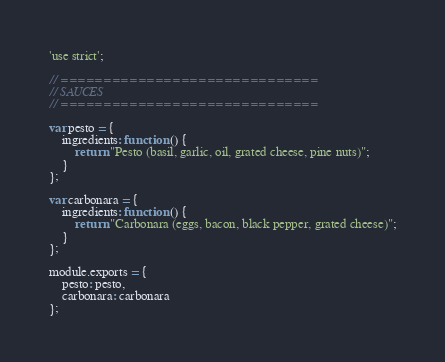Convert code to text. <code><loc_0><loc_0><loc_500><loc_500><_JavaScript_>'use strict';

// ==============================
// SAUCES
// ==============================

var pesto = {
    ingredients: function () {
        return "Pesto (basil, garlic, oil, grated cheese, pine nuts)";
    }
};

var carbonara = {
    ingredients: function () {
        return "Carbonara (eggs, bacon, black pepper, grated cheese)";
    }
};

module.exports = {
    pesto: pesto,
    carbonara: carbonara
};
</code> 